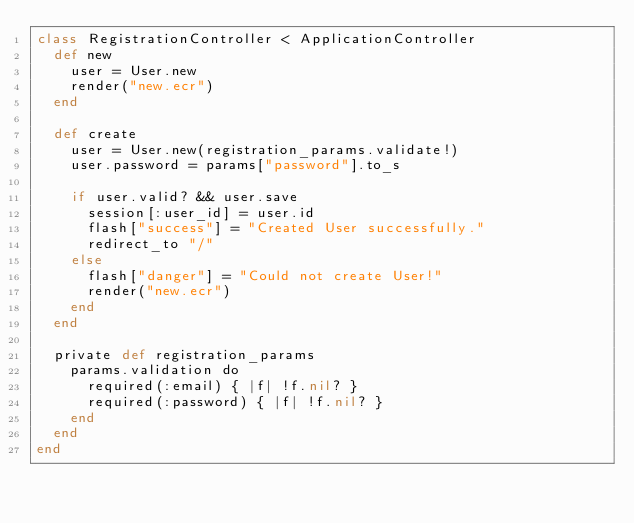<code> <loc_0><loc_0><loc_500><loc_500><_Crystal_>class RegistrationController < ApplicationController
  def new
    user = User.new
    render("new.ecr")
  end

  def create
    user = User.new(registration_params.validate!)
    user.password = params["password"].to_s

    if user.valid? && user.save
      session[:user_id] = user.id
      flash["success"] = "Created User successfully."
      redirect_to "/"
    else
      flash["danger"] = "Could not create User!"
      render("new.ecr")
    end
  end

  private def registration_params
    params.validation do
      required(:email) { |f| !f.nil? }
      required(:password) { |f| !f.nil? }
    end
  end
end
</code> 